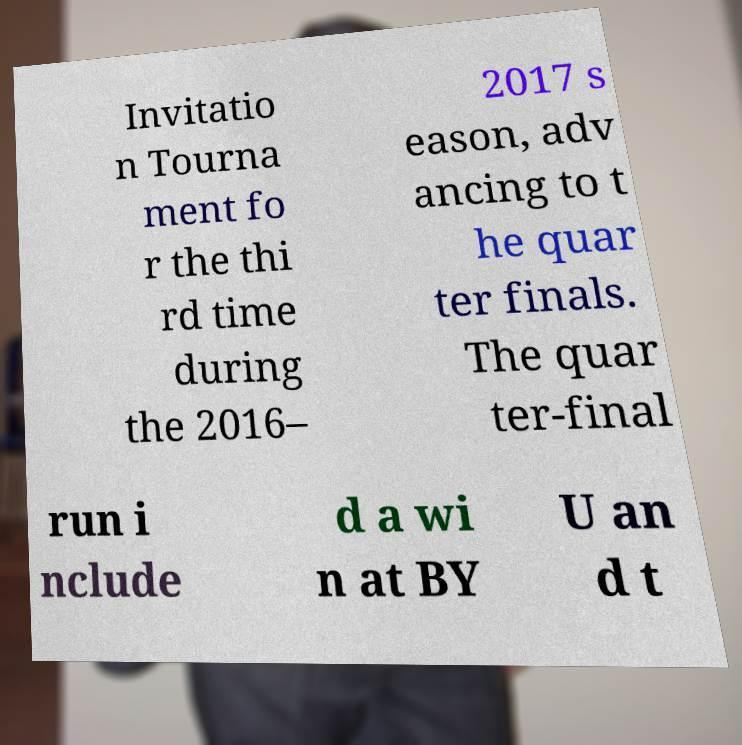Please read and relay the text visible in this image. What does it say? Invitatio n Tourna ment fo r the thi rd time during the 2016– 2017 s eason, adv ancing to t he quar ter finals. The quar ter-final run i nclude d a wi n at BY U an d t 